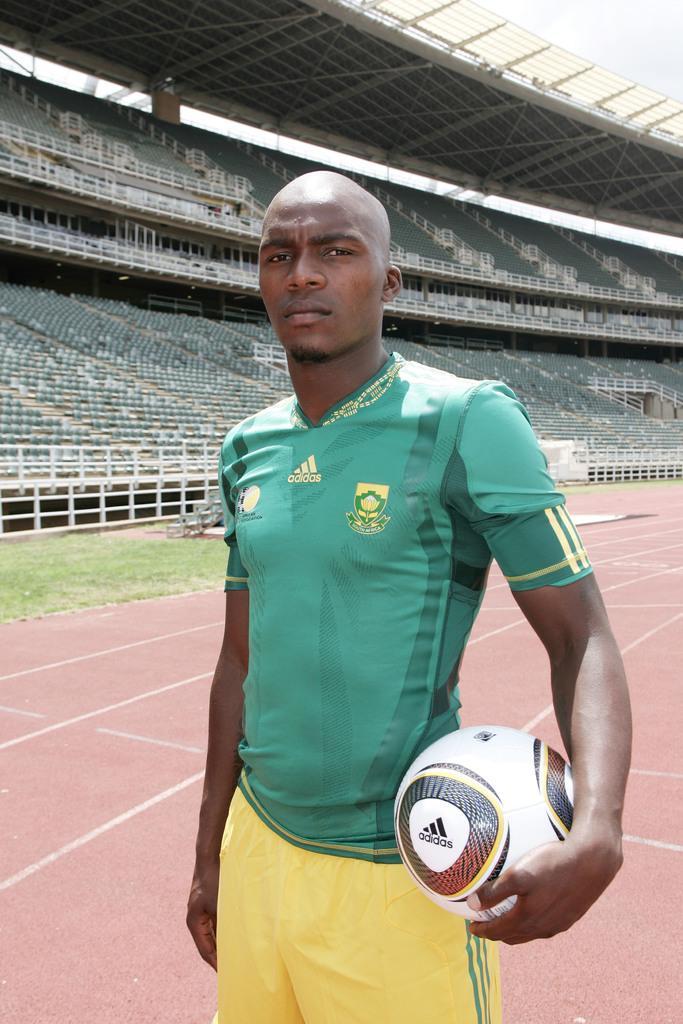Describe this image in one or two sentences. A man is posing to camera with a football in his hand in a stadium. 